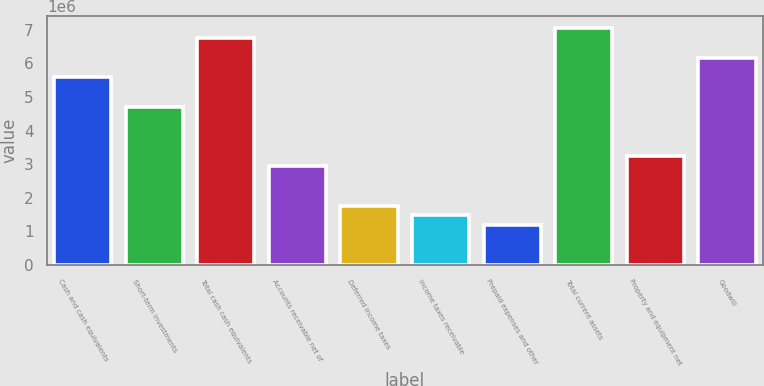<chart> <loc_0><loc_0><loc_500><loc_500><bar_chart><fcel>Cash and cash equivalents<fcel>Short-term investments<fcel>Total cash cash equivalents<fcel>Accounts receivable net of<fcel>Deferred income taxes<fcel>Income taxes receivable<fcel>Prepaid expenses and other<fcel>Total current assets<fcel>Property and equipment net<fcel>Goodwill<nl><fcel>5.5825e+06<fcel>4.70128e+06<fcel>6.75745e+06<fcel>2.93885e+06<fcel>1.7639e+06<fcel>1.47016e+06<fcel>1.17642e+06<fcel>7.05119e+06<fcel>3.23259e+06<fcel>6.16998e+06<nl></chart> 